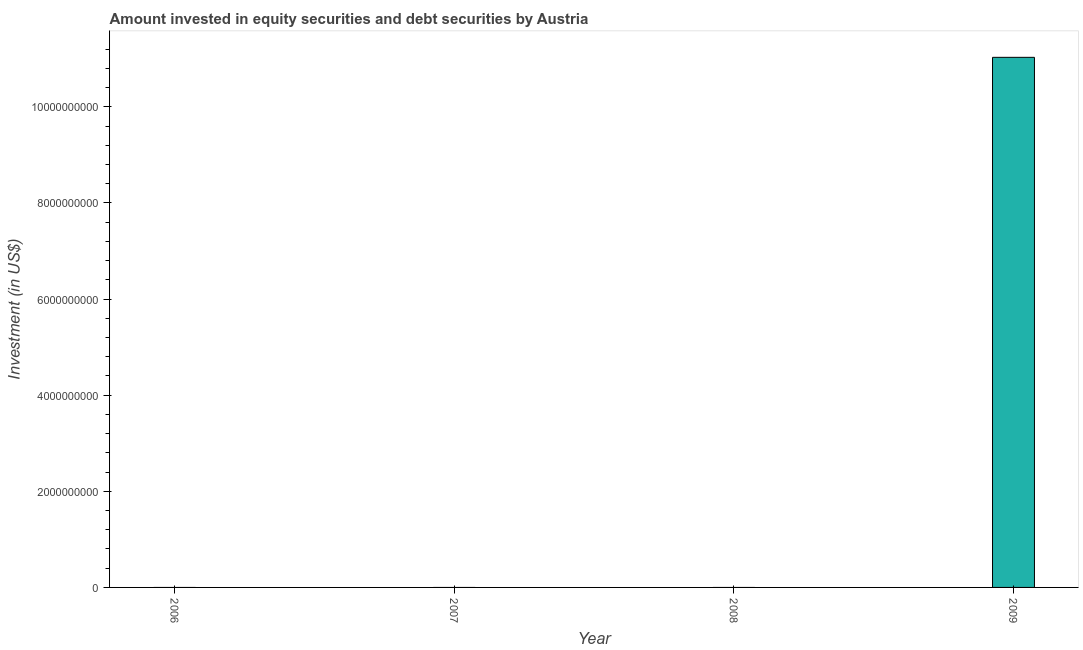Does the graph contain any zero values?
Give a very brief answer. Yes. Does the graph contain grids?
Your answer should be compact. No. What is the title of the graph?
Offer a terse response. Amount invested in equity securities and debt securities by Austria. What is the label or title of the Y-axis?
Keep it short and to the point. Investment (in US$). What is the portfolio investment in 2008?
Offer a terse response. 0. Across all years, what is the maximum portfolio investment?
Offer a very short reply. 1.10e+1. In which year was the portfolio investment maximum?
Your answer should be compact. 2009. What is the sum of the portfolio investment?
Keep it short and to the point. 1.10e+1. What is the average portfolio investment per year?
Offer a very short reply. 2.76e+09. What is the median portfolio investment?
Ensure brevity in your answer.  0. What is the difference between the highest and the lowest portfolio investment?
Make the answer very short. 1.10e+1. In how many years, is the portfolio investment greater than the average portfolio investment taken over all years?
Make the answer very short. 1. Are all the bars in the graph horizontal?
Give a very brief answer. No. What is the difference between two consecutive major ticks on the Y-axis?
Make the answer very short. 2.00e+09. Are the values on the major ticks of Y-axis written in scientific E-notation?
Ensure brevity in your answer.  No. What is the Investment (in US$) of 2009?
Your answer should be compact. 1.10e+1. 